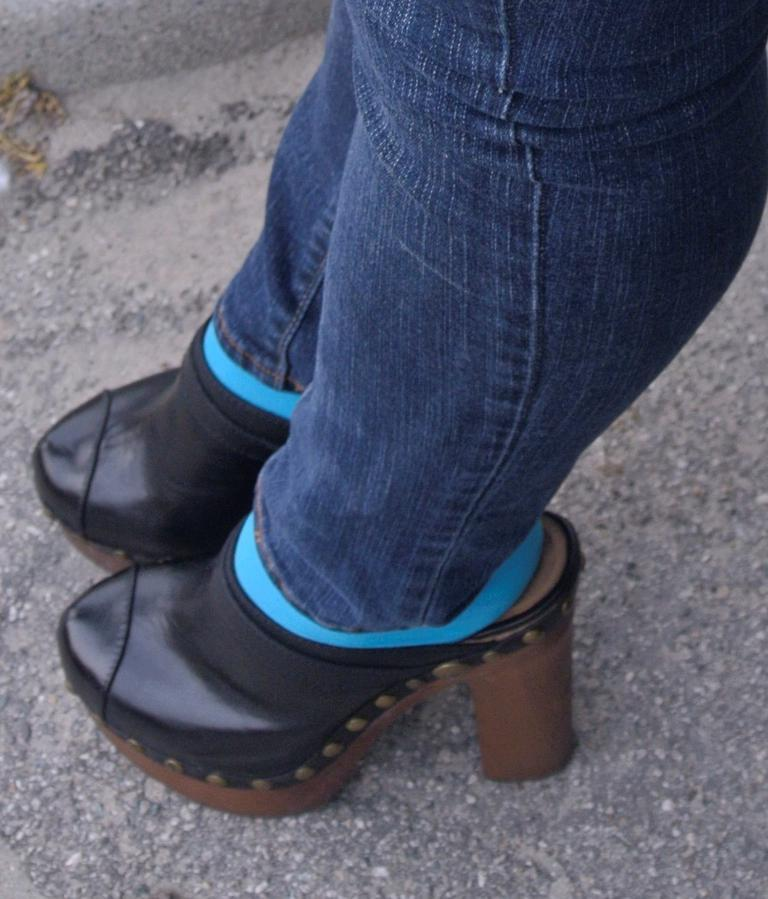What type of pants is the person in the image wearing? The person in the image is wearing blue jeans. What color are the socks the person is wearing? The person is wearing blue socks. What type of footwear is the person wearing? The person is wearing black sandals. What can be seen at the bottom of the image? The surface of the road is visible at the bottom of the image. What journey is the person in the image embarking on? There is no indication of a journey in the image; it only shows the person's clothing and the road surface. 